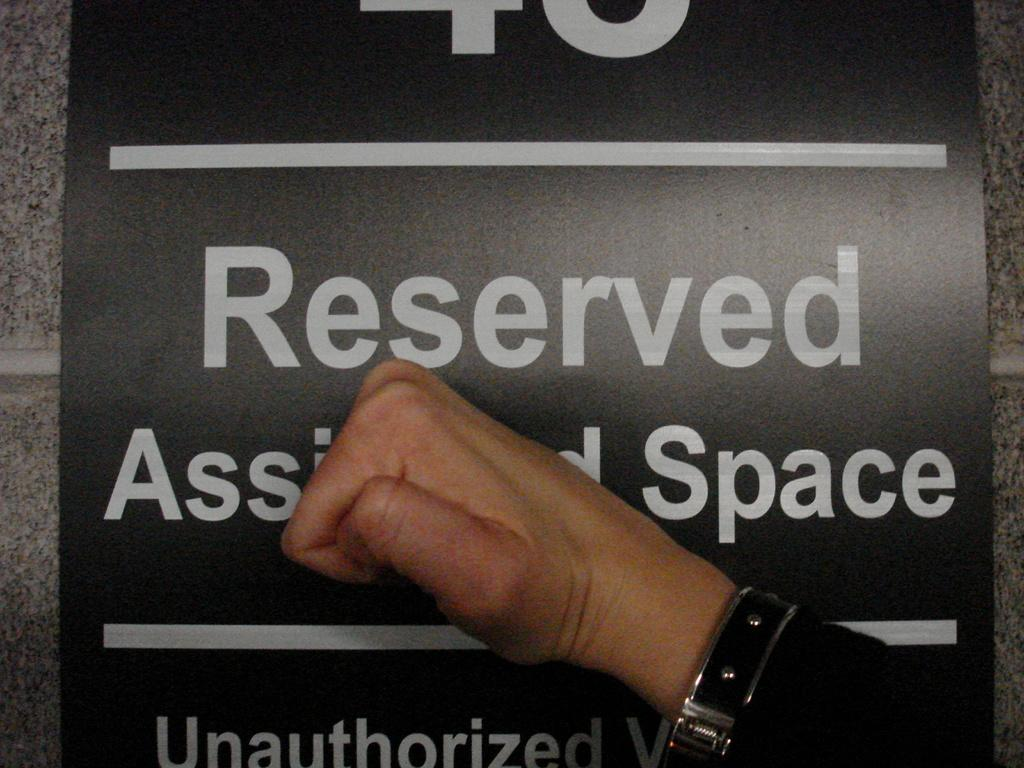<image>
Offer a succinct explanation of the picture presented. A black placard with white lettering with the words Reserved Space on it. 